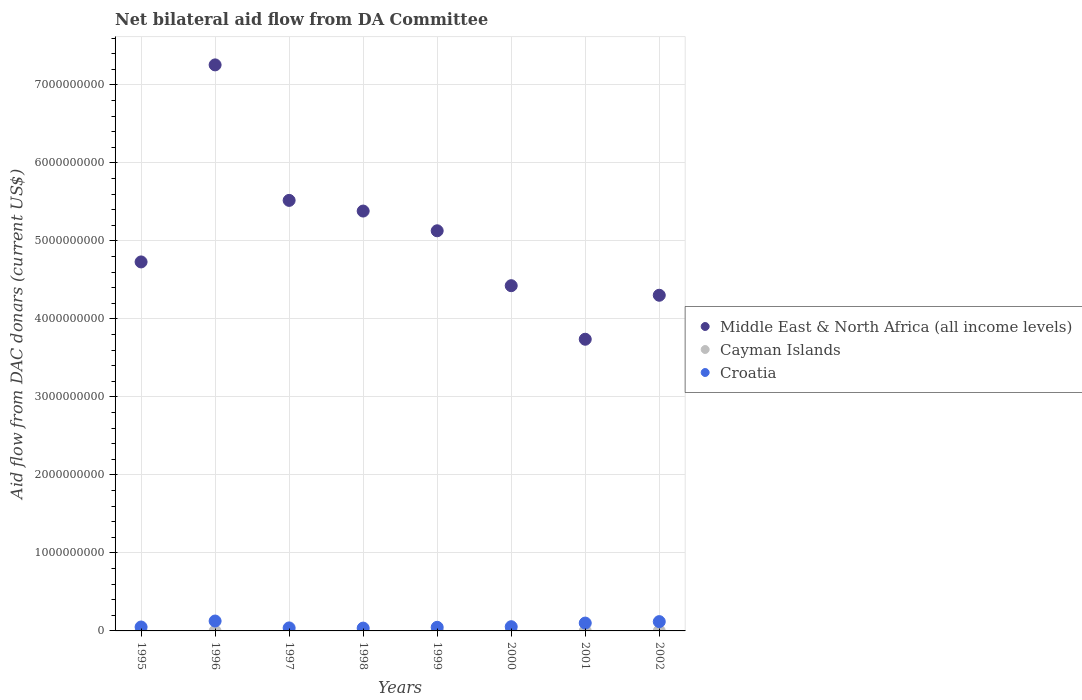What is the aid flow in in Middle East & North Africa (all income levels) in 1997?
Offer a very short reply. 5.52e+09. Across all years, what is the maximum aid flow in in Cayman Islands?
Provide a succinct answer. 3.29e+06. Across all years, what is the minimum aid flow in in Middle East & North Africa (all income levels)?
Make the answer very short. 3.74e+09. What is the total aid flow in in Middle East & North Africa (all income levels) in the graph?
Give a very brief answer. 4.05e+1. What is the difference between the aid flow in in Croatia in 1996 and that in 1999?
Ensure brevity in your answer.  8.06e+07. What is the difference between the aid flow in in Middle East & North Africa (all income levels) in 2002 and the aid flow in in Croatia in 1997?
Ensure brevity in your answer.  4.26e+09. What is the average aid flow in in Cayman Islands per year?
Make the answer very short. 4.40e+05. In the year 1999, what is the difference between the aid flow in in Middle East & North Africa (all income levels) and aid flow in in Cayman Islands?
Your answer should be compact. 5.13e+09. What is the ratio of the aid flow in in Middle East & North Africa (all income levels) in 1997 to that in 2002?
Make the answer very short. 1.28. What is the difference between the highest and the second highest aid flow in in Middle East & North Africa (all income levels)?
Keep it short and to the point. 1.74e+09. What is the difference between the highest and the lowest aid flow in in Middle East & North Africa (all income levels)?
Keep it short and to the point. 3.52e+09. Is it the case that in every year, the sum of the aid flow in in Middle East & North Africa (all income levels) and aid flow in in Cayman Islands  is greater than the aid flow in in Croatia?
Offer a very short reply. Yes. Is the aid flow in in Middle East & North Africa (all income levels) strictly greater than the aid flow in in Croatia over the years?
Make the answer very short. Yes. Is the aid flow in in Cayman Islands strictly less than the aid flow in in Croatia over the years?
Offer a terse response. Yes. How many dotlines are there?
Offer a very short reply. 3. How many years are there in the graph?
Your answer should be very brief. 8. What is the difference between two consecutive major ticks on the Y-axis?
Give a very brief answer. 1.00e+09. Where does the legend appear in the graph?
Ensure brevity in your answer.  Center right. How many legend labels are there?
Ensure brevity in your answer.  3. What is the title of the graph?
Your response must be concise. Net bilateral aid flow from DA Committee. What is the label or title of the X-axis?
Make the answer very short. Years. What is the label or title of the Y-axis?
Provide a succinct answer. Aid flow from DAC donars (current US$). What is the Aid flow from DAC donars (current US$) in Middle East & North Africa (all income levels) in 1995?
Your answer should be very brief. 4.73e+09. What is the Aid flow from DAC donars (current US$) of Cayman Islands in 1995?
Provide a short and direct response. 0. What is the Aid flow from DAC donars (current US$) of Croatia in 1995?
Ensure brevity in your answer.  5.02e+07. What is the Aid flow from DAC donars (current US$) in Middle East & North Africa (all income levels) in 1996?
Ensure brevity in your answer.  7.26e+09. What is the Aid flow from DAC donars (current US$) in Cayman Islands in 1996?
Ensure brevity in your answer.  0. What is the Aid flow from DAC donars (current US$) of Croatia in 1996?
Offer a very short reply. 1.27e+08. What is the Aid flow from DAC donars (current US$) of Middle East & North Africa (all income levels) in 1997?
Ensure brevity in your answer.  5.52e+09. What is the Aid flow from DAC donars (current US$) in Croatia in 1997?
Your answer should be compact. 3.85e+07. What is the Aid flow from DAC donars (current US$) in Middle East & North Africa (all income levels) in 1998?
Your answer should be compact. 5.38e+09. What is the Aid flow from DAC donars (current US$) of Cayman Islands in 1998?
Offer a terse response. 2.30e+05. What is the Aid flow from DAC donars (current US$) in Croatia in 1998?
Your response must be concise. 3.61e+07. What is the Aid flow from DAC donars (current US$) in Middle East & North Africa (all income levels) in 1999?
Your answer should be very brief. 5.13e+09. What is the Aid flow from DAC donars (current US$) in Cayman Islands in 1999?
Provide a succinct answer. 3.29e+06. What is the Aid flow from DAC donars (current US$) in Croatia in 1999?
Provide a short and direct response. 4.63e+07. What is the Aid flow from DAC donars (current US$) in Middle East & North Africa (all income levels) in 2000?
Offer a very short reply. 4.43e+09. What is the Aid flow from DAC donars (current US$) of Cayman Islands in 2000?
Provide a short and direct response. 0. What is the Aid flow from DAC donars (current US$) of Croatia in 2000?
Give a very brief answer. 5.41e+07. What is the Aid flow from DAC donars (current US$) of Middle East & North Africa (all income levels) in 2001?
Offer a terse response. 3.74e+09. What is the Aid flow from DAC donars (current US$) of Cayman Islands in 2001?
Your answer should be very brief. 0. What is the Aid flow from DAC donars (current US$) in Croatia in 2001?
Give a very brief answer. 1.01e+08. What is the Aid flow from DAC donars (current US$) of Middle East & North Africa (all income levels) in 2002?
Your answer should be very brief. 4.30e+09. What is the Aid flow from DAC donars (current US$) of Cayman Islands in 2002?
Provide a succinct answer. 0. What is the Aid flow from DAC donars (current US$) in Croatia in 2002?
Offer a very short reply. 1.19e+08. Across all years, what is the maximum Aid flow from DAC donars (current US$) of Middle East & North Africa (all income levels)?
Offer a very short reply. 7.26e+09. Across all years, what is the maximum Aid flow from DAC donars (current US$) of Cayman Islands?
Provide a succinct answer. 3.29e+06. Across all years, what is the maximum Aid flow from DAC donars (current US$) of Croatia?
Give a very brief answer. 1.27e+08. Across all years, what is the minimum Aid flow from DAC donars (current US$) in Middle East & North Africa (all income levels)?
Offer a terse response. 3.74e+09. Across all years, what is the minimum Aid flow from DAC donars (current US$) in Cayman Islands?
Offer a very short reply. 0. Across all years, what is the minimum Aid flow from DAC donars (current US$) in Croatia?
Offer a terse response. 3.61e+07. What is the total Aid flow from DAC donars (current US$) of Middle East & North Africa (all income levels) in the graph?
Offer a very short reply. 4.05e+1. What is the total Aid flow from DAC donars (current US$) in Cayman Islands in the graph?
Your answer should be compact. 3.52e+06. What is the total Aid flow from DAC donars (current US$) in Croatia in the graph?
Make the answer very short. 5.72e+08. What is the difference between the Aid flow from DAC donars (current US$) of Middle East & North Africa (all income levels) in 1995 and that in 1996?
Give a very brief answer. -2.53e+09. What is the difference between the Aid flow from DAC donars (current US$) of Croatia in 1995 and that in 1996?
Make the answer very short. -7.67e+07. What is the difference between the Aid flow from DAC donars (current US$) in Middle East & North Africa (all income levels) in 1995 and that in 1997?
Your answer should be compact. -7.89e+08. What is the difference between the Aid flow from DAC donars (current US$) in Croatia in 1995 and that in 1997?
Provide a succinct answer. 1.17e+07. What is the difference between the Aid flow from DAC donars (current US$) of Middle East & North Africa (all income levels) in 1995 and that in 1998?
Your response must be concise. -6.52e+08. What is the difference between the Aid flow from DAC donars (current US$) of Croatia in 1995 and that in 1998?
Your response must be concise. 1.41e+07. What is the difference between the Aid flow from DAC donars (current US$) in Middle East & North Africa (all income levels) in 1995 and that in 1999?
Offer a terse response. -3.99e+08. What is the difference between the Aid flow from DAC donars (current US$) of Croatia in 1995 and that in 1999?
Your response must be concise. 3.92e+06. What is the difference between the Aid flow from DAC donars (current US$) of Middle East & North Africa (all income levels) in 1995 and that in 2000?
Offer a very short reply. 3.05e+08. What is the difference between the Aid flow from DAC donars (current US$) in Croatia in 1995 and that in 2000?
Your answer should be very brief. -3.86e+06. What is the difference between the Aid flow from DAC donars (current US$) of Middle East & North Africa (all income levels) in 1995 and that in 2001?
Your answer should be compact. 9.91e+08. What is the difference between the Aid flow from DAC donars (current US$) of Croatia in 1995 and that in 2001?
Keep it short and to the point. -5.04e+07. What is the difference between the Aid flow from DAC donars (current US$) of Middle East & North Africa (all income levels) in 1995 and that in 2002?
Provide a short and direct response. 4.27e+08. What is the difference between the Aid flow from DAC donars (current US$) of Croatia in 1995 and that in 2002?
Provide a short and direct response. -6.90e+07. What is the difference between the Aid flow from DAC donars (current US$) of Middle East & North Africa (all income levels) in 1996 and that in 1997?
Offer a very short reply. 1.74e+09. What is the difference between the Aid flow from DAC donars (current US$) in Croatia in 1996 and that in 1997?
Give a very brief answer. 8.84e+07. What is the difference between the Aid flow from DAC donars (current US$) in Middle East & North Africa (all income levels) in 1996 and that in 1998?
Give a very brief answer. 1.87e+09. What is the difference between the Aid flow from DAC donars (current US$) of Croatia in 1996 and that in 1998?
Keep it short and to the point. 9.08e+07. What is the difference between the Aid flow from DAC donars (current US$) of Middle East & North Africa (all income levels) in 1996 and that in 1999?
Ensure brevity in your answer.  2.13e+09. What is the difference between the Aid flow from DAC donars (current US$) of Croatia in 1996 and that in 1999?
Your response must be concise. 8.06e+07. What is the difference between the Aid flow from DAC donars (current US$) in Middle East & North Africa (all income levels) in 1996 and that in 2000?
Your response must be concise. 2.83e+09. What is the difference between the Aid flow from DAC donars (current US$) in Croatia in 1996 and that in 2000?
Your answer should be compact. 7.28e+07. What is the difference between the Aid flow from DAC donars (current US$) in Middle East & North Africa (all income levels) in 1996 and that in 2001?
Ensure brevity in your answer.  3.52e+09. What is the difference between the Aid flow from DAC donars (current US$) in Croatia in 1996 and that in 2001?
Ensure brevity in your answer.  2.62e+07. What is the difference between the Aid flow from DAC donars (current US$) in Middle East & North Africa (all income levels) in 1996 and that in 2002?
Offer a terse response. 2.95e+09. What is the difference between the Aid flow from DAC donars (current US$) of Croatia in 1996 and that in 2002?
Offer a very short reply. 7.61e+06. What is the difference between the Aid flow from DAC donars (current US$) of Middle East & North Africa (all income levels) in 1997 and that in 1998?
Make the answer very short. 1.37e+08. What is the difference between the Aid flow from DAC donars (current US$) in Croatia in 1997 and that in 1998?
Keep it short and to the point. 2.40e+06. What is the difference between the Aid flow from DAC donars (current US$) in Middle East & North Africa (all income levels) in 1997 and that in 1999?
Make the answer very short. 3.90e+08. What is the difference between the Aid flow from DAC donars (current US$) in Croatia in 1997 and that in 1999?
Give a very brief answer. -7.78e+06. What is the difference between the Aid flow from DAC donars (current US$) in Middle East & North Africa (all income levels) in 1997 and that in 2000?
Your response must be concise. 1.09e+09. What is the difference between the Aid flow from DAC donars (current US$) in Croatia in 1997 and that in 2000?
Your answer should be very brief. -1.56e+07. What is the difference between the Aid flow from DAC donars (current US$) of Middle East & North Africa (all income levels) in 1997 and that in 2001?
Make the answer very short. 1.78e+09. What is the difference between the Aid flow from DAC donars (current US$) of Croatia in 1997 and that in 2001?
Offer a very short reply. -6.21e+07. What is the difference between the Aid flow from DAC donars (current US$) in Middle East & North Africa (all income levels) in 1997 and that in 2002?
Offer a very short reply. 1.22e+09. What is the difference between the Aid flow from DAC donars (current US$) in Croatia in 1997 and that in 2002?
Your response must be concise. -8.08e+07. What is the difference between the Aid flow from DAC donars (current US$) in Middle East & North Africa (all income levels) in 1998 and that in 1999?
Give a very brief answer. 2.53e+08. What is the difference between the Aid flow from DAC donars (current US$) of Cayman Islands in 1998 and that in 1999?
Offer a very short reply. -3.06e+06. What is the difference between the Aid flow from DAC donars (current US$) in Croatia in 1998 and that in 1999?
Offer a terse response. -1.02e+07. What is the difference between the Aid flow from DAC donars (current US$) in Middle East & North Africa (all income levels) in 1998 and that in 2000?
Your answer should be very brief. 9.57e+08. What is the difference between the Aid flow from DAC donars (current US$) of Croatia in 1998 and that in 2000?
Make the answer very short. -1.80e+07. What is the difference between the Aid flow from DAC donars (current US$) in Middle East & North Africa (all income levels) in 1998 and that in 2001?
Your answer should be very brief. 1.64e+09. What is the difference between the Aid flow from DAC donars (current US$) in Croatia in 1998 and that in 2001?
Your response must be concise. -6.45e+07. What is the difference between the Aid flow from DAC donars (current US$) of Middle East & North Africa (all income levels) in 1998 and that in 2002?
Provide a succinct answer. 1.08e+09. What is the difference between the Aid flow from DAC donars (current US$) in Croatia in 1998 and that in 2002?
Your response must be concise. -8.32e+07. What is the difference between the Aid flow from DAC donars (current US$) in Middle East & North Africa (all income levels) in 1999 and that in 2000?
Offer a very short reply. 7.04e+08. What is the difference between the Aid flow from DAC donars (current US$) of Croatia in 1999 and that in 2000?
Offer a terse response. -7.78e+06. What is the difference between the Aid flow from DAC donars (current US$) in Middle East & North Africa (all income levels) in 1999 and that in 2001?
Offer a terse response. 1.39e+09. What is the difference between the Aid flow from DAC donars (current US$) in Croatia in 1999 and that in 2001?
Your response must be concise. -5.44e+07. What is the difference between the Aid flow from DAC donars (current US$) in Middle East & North Africa (all income levels) in 1999 and that in 2002?
Ensure brevity in your answer.  8.26e+08. What is the difference between the Aid flow from DAC donars (current US$) of Croatia in 1999 and that in 2002?
Ensure brevity in your answer.  -7.30e+07. What is the difference between the Aid flow from DAC donars (current US$) of Middle East & North Africa (all income levels) in 2000 and that in 2001?
Provide a short and direct response. 6.86e+08. What is the difference between the Aid flow from DAC donars (current US$) of Croatia in 2000 and that in 2001?
Ensure brevity in your answer.  -4.66e+07. What is the difference between the Aid flow from DAC donars (current US$) in Middle East & North Africa (all income levels) in 2000 and that in 2002?
Ensure brevity in your answer.  1.23e+08. What is the difference between the Aid flow from DAC donars (current US$) of Croatia in 2000 and that in 2002?
Your answer should be very brief. -6.52e+07. What is the difference between the Aid flow from DAC donars (current US$) in Middle East & North Africa (all income levels) in 2001 and that in 2002?
Provide a short and direct response. -5.64e+08. What is the difference between the Aid flow from DAC donars (current US$) in Croatia in 2001 and that in 2002?
Offer a very short reply. -1.86e+07. What is the difference between the Aid flow from DAC donars (current US$) in Middle East & North Africa (all income levels) in 1995 and the Aid flow from DAC donars (current US$) in Croatia in 1996?
Keep it short and to the point. 4.60e+09. What is the difference between the Aid flow from DAC donars (current US$) of Middle East & North Africa (all income levels) in 1995 and the Aid flow from DAC donars (current US$) of Croatia in 1997?
Keep it short and to the point. 4.69e+09. What is the difference between the Aid flow from DAC donars (current US$) of Middle East & North Africa (all income levels) in 1995 and the Aid flow from DAC donars (current US$) of Cayman Islands in 1998?
Offer a very short reply. 4.73e+09. What is the difference between the Aid flow from DAC donars (current US$) of Middle East & North Africa (all income levels) in 1995 and the Aid flow from DAC donars (current US$) of Croatia in 1998?
Your response must be concise. 4.69e+09. What is the difference between the Aid flow from DAC donars (current US$) in Middle East & North Africa (all income levels) in 1995 and the Aid flow from DAC donars (current US$) in Cayman Islands in 1999?
Offer a terse response. 4.73e+09. What is the difference between the Aid flow from DAC donars (current US$) of Middle East & North Africa (all income levels) in 1995 and the Aid flow from DAC donars (current US$) of Croatia in 1999?
Provide a short and direct response. 4.68e+09. What is the difference between the Aid flow from DAC donars (current US$) in Middle East & North Africa (all income levels) in 1995 and the Aid flow from DAC donars (current US$) in Croatia in 2000?
Your response must be concise. 4.68e+09. What is the difference between the Aid flow from DAC donars (current US$) in Middle East & North Africa (all income levels) in 1995 and the Aid flow from DAC donars (current US$) in Croatia in 2001?
Your response must be concise. 4.63e+09. What is the difference between the Aid flow from DAC donars (current US$) in Middle East & North Africa (all income levels) in 1995 and the Aid flow from DAC donars (current US$) in Croatia in 2002?
Your response must be concise. 4.61e+09. What is the difference between the Aid flow from DAC donars (current US$) in Middle East & North Africa (all income levels) in 1996 and the Aid flow from DAC donars (current US$) in Croatia in 1997?
Your response must be concise. 7.22e+09. What is the difference between the Aid flow from DAC donars (current US$) of Middle East & North Africa (all income levels) in 1996 and the Aid flow from DAC donars (current US$) of Cayman Islands in 1998?
Keep it short and to the point. 7.26e+09. What is the difference between the Aid flow from DAC donars (current US$) of Middle East & North Africa (all income levels) in 1996 and the Aid flow from DAC donars (current US$) of Croatia in 1998?
Offer a terse response. 7.22e+09. What is the difference between the Aid flow from DAC donars (current US$) in Middle East & North Africa (all income levels) in 1996 and the Aid flow from DAC donars (current US$) in Cayman Islands in 1999?
Your response must be concise. 7.25e+09. What is the difference between the Aid flow from DAC donars (current US$) in Middle East & North Africa (all income levels) in 1996 and the Aid flow from DAC donars (current US$) in Croatia in 1999?
Your answer should be very brief. 7.21e+09. What is the difference between the Aid flow from DAC donars (current US$) of Middle East & North Africa (all income levels) in 1996 and the Aid flow from DAC donars (current US$) of Croatia in 2000?
Give a very brief answer. 7.20e+09. What is the difference between the Aid flow from DAC donars (current US$) in Middle East & North Africa (all income levels) in 1996 and the Aid flow from DAC donars (current US$) in Croatia in 2001?
Offer a very short reply. 7.16e+09. What is the difference between the Aid flow from DAC donars (current US$) in Middle East & North Africa (all income levels) in 1996 and the Aid flow from DAC donars (current US$) in Croatia in 2002?
Keep it short and to the point. 7.14e+09. What is the difference between the Aid flow from DAC donars (current US$) of Middle East & North Africa (all income levels) in 1997 and the Aid flow from DAC donars (current US$) of Cayman Islands in 1998?
Offer a terse response. 5.52e+09. What is the difference between the Aid flow from DAC donars (current US$) of Middle East & North Africa (all income levels) in 1997 and the Aid flow from DAC donars (current US$) of Croatia in 1998?
Your answer should be compact. 5.48e+09. What is the difference between the Aid flow from DAC donars (current US$) in Middle East & North Africa (all income levels) in 1997 and the Aid flow from DAC donars (current US$) in Cayman Islands in 1999?
Offer a very short reply. 5.52e+09. What is the difference between the Aid flow from DAC donars (current US$) in Middle East & North Africa (all income levels) in 1997 and the Aid flow from DAC donars (current US$) in Croatia in 1999?
Ensure brevity in your answer.  5.47e+09. What is the difference between the Aid flow from DAC donars (current US$) in Middle East & North Africa (all income levels) in 1997 and the Aid flow from DAC donars (current US$) in Croatia in 2000?
Offer a terse response. 5.46e+09. What is the difference between the Aid flow from DAC donars (current US$) of Middle East & North Africa (all income levels) in 1997 and the Aid flow from DAC donars (current US$) of Croatia in 2001?
Keep it short and to the point. 5.42e+09. What is the difference between the Aid flow from DAC donars (current US$) of Middle East & North Africa (all income levels) in 1997 and the Aid flow from DAC donars (current US$) of Croatia in 2002?
Offer a very short reply. 5.40e+09. What is the difference between the Aid flow from DAC donars (current US$) of Middle East & North Africa (all income levels) in 1998 and the Aid flow from DAC donars (current US$) of Cayman Islands in 1999?
Keep it short and to the point. 5.38e+09. What is the difference between the Aid flow from DAC donars (current US$) of Middle East & North Africa (all income levels) in 1998 and the Aid flow from DAC donars (current US$) of Croatia in 1999?
Your answer should be very brief. 5.34e+09. What is the difference between the Aid flow from DAC donars (current US$) in Cayman Islands in 1998 and the Aid flow from DAC donars (current US$) in Croatia in 1999?
Give a very brief answer. -4.61e+07. What is the difference between the Aid flow from DAC donars (current US$) in Middle East & North Africa (all income levels) in 1998 and the Aid flow from DAC donars (current US$) in Croatia in 2000?
Make the answer very short. 5.33e+09. What is the difference between the Aid flow from DAC donars (current US$) of Cayman Islands in 1998 and the Aid flow from DAC donars (current US$) of Croatia in 2000?
Your answer should be very brief. -5.38e+07. What is the difference between the Aid flow from DAC donars (current US$) of Middle East & North Africa (all income levels) in 1998 and the Aid flow from DAC donars (current US$) of Croatia in 2001?
Ensure brevity in your answer.  5.28e+09. What is the difference between the Aid flow from DAC donars (current US$) of Cayman Islands in 1998 and the Aid flow from DAC donars (current US$) of Croatia in 2001?
Your answer should be compact. -1.00e+08. What is the difference between the Aid flow from DAC donars (current US$) in Middle East & North Africa (all income levels) in 1998 and the Aid flow from DAC donars (current US$) in Croatia in 2002?
Keep it short and to the point. 5.26e+09. What is the difference between the Aid flow from DAC donars (current US$) of Cayman Islands in 1998 and the Aid flow from DAC donars (current US$) of Croatia in 2002?
Offer a terse response. -1.19e+08. What is the difference between the Aid flow from DAC donars (current US$) in Middle East & North Africa (all income levels) in 1999 and the Aid flow from DAC donars (current US$) in Croatia in 2000?
Keep it short and to the point. 5.08e+09. What is the difference between the Aid flow from DAC donars (current US$) in Cayman Islands in 1999 and the Aid flow from DAC donars (current US$) in Croatia in 2000?
Give a very brief answer. -5.08e+07. What is the difference between the Aid flow from DAC donars (current US$) of Middle East & North Africa (all income levels) in 1999 and the Aid flow from DAC donars (current US$) of Croatia in 2001?
Keep it short and to the point. 5.03e+09. What is the difference between the Aid flow from DAC donars (current US$) in Cayman Islands in 1999 and the Aid flow from DAC donars (current US$) in Croatia in 2001?
Make the answer very short. -9.74e+07. What is the difference between the Aid flow from DAC donars (current US$) of Middle East & North Africa (all income levels) in 1999 and the Aid flow from DAC donars (current US$) of Croatia in 2002?
Provide a succinct answer. 5.01e+09. What is the difference between the Aid flow from DAC donars (current US$) of Cayman Islands in 1999 and the Aid flow from DAC donars (current US$) of Croatia in 2002?
Your response must be concise. -1.16e+08. What is the difference between the Aid flow from DAC donars (current US$) of Middle East & North Africa (all income levels) in 2000 and the Aid flow from DAC donars (current US$) of Croatia in 2001?
Provide a short and direct response. 4.32e+09. What is the difference between the Aid flow from DAC donars (current US$) in Middle East & North Africa (all income levels) in 2000 and the Aid flow from DAC donars (current US$) in Croatia in 2002?
Your answer should be compact. 4.31e+09. What is the difference between the Aid flow from DAC donars (current US$) of Middle East & North Africa (all income levels) in 2001 and the Aid flow from DAC donars (current US$) of Croatia in 2002?
Keep it short and to the point. 3.62e+09. What is the average Aid flow from DAC donars (current US$) of Middle East & North Africa (all income levels) per year?
Your answer should be very brief. 5.06e+09. What is the average Aid flow from DAC donars (current US$) of Croatia per year?
Your answer should be very brief. 7.15e+07. In the year 1995, what is the difference between the Aid flow from DAC donars (current US$) of Middle East & North Africa (all income levels) and Aid flow from DAC donars (current US$) of Croatia?
Ensure brevity in your answer.  4.68e+09. In the year 1996, what is the difference between the Aid flow from DAC donars (current US$) in Middle East & North Africa (all income levels) and Aid flow from DAC donars (current US$) in Croatia?
Offer a very short reply. 7.13e+09. In the year 1997, what is the difference between the Aid flow from DAC donars (current US$) of Middle East & North Africa (all income levels) and Aid flow from DAC donars (current US$) of Croatia?
Provide a short and direct response. 5.48e+09. In the year 1998, what is the difference between the Aid flow from DAC donars (current US$) in Middle East & North Africa (all income levels) and Aid flow from DAC donars (current US$) in Cayman Islands?
Offer a terse response. 5.38e+09. In the year 1998, what is the difference between the Aid flow from DAC donars (current US$) of Middle East & North Africa (all income levels) and Aid flow from DAC donars (current US$) of Croatia?
Offer a very short reply. 5.35e+09. In the year 1998, what is the difference between the Aid flow from DAC donars (current US$) of Cayman Islands and Aid flow from DAC donars (current US$) of Croatia?
Offer a very short reply. -3.59e+07. In the year 1999, what is the difference between the Aid flow from DAC donars (current US$) in Middle East & North Africa (all income levels) and Aid flow from DAC donars (current US$) in Cayman Islands?
Keep it short and to the point. 5.13e+09. In the year 1999, what is the difference between the Aid flow from DAC donars (current US$) of Middle East & North Africa (all income levels) and Aid flow from DAC donars (current US$) of Croatia?
Make the answer very short. 5.08e+09. In the year 1999, what is the difference between the Aid flow from DAC donars (current US$) of Cayman Islands and Aid flow from DAC donars (current US$) of Croatia?
Your answer should be compact. -4.30e+07. In the year 2000, what is the difference between the Aid flow from DAC donars (current US$) of Middle East & North Africa (all income levels) and Aid flow from DAC donars (current US$) of Croatia?
Your response must be concise. 4.37e+09. In the year 2001, what is the difference between the Aid flow from DAC donars (current US$) of Middle East & North Africa (all income levels) and Aid flow from DAC donars (current US$) of Croatia?
Provide a succinct answer. 3.64e+09. In the year 2002, what is the difference between the Aid flow from DAC donars (current US$) in Middle East & North Africa (all income levels) and Aid flow from DAC donars (current US$) in Croatia?
Your answer should be compact. 4.18e+09. What is the ratio of the Aid flow from DAC donars (current US$) of Middle East & North Africa (all income levels) in 1995 to that in 1996?
Keep it short and to the point. 0.65. What is the ratio of the Aid flow from DAC donars (current US$) in Croatia in 1995 to that in 1996?
Make the answer very short. 0.4. What is the ratio of the Aid flow from DAC donars (current US$) of Middle East & North Africa (all income levels) in 1995 to that in 1997?
Your answer should be very brief. 0.86. What is the ratio of the Aid flow from DAC donars (current US$) of Croatia in 1995 to that in 1997?
Ensure brevity in your answer.  1.3. What is the ratio of the Aid flow from DAC donars (current US$) in Middle East & North Africa (all income levels) in 1995 to that in 1998?
Your response must be concise. 0.88. What is the ratio of the Aid flow from DAC donars (current US$) of Croatia in 1995 to that in 1998?
Keep it short and to the point. 1.39. What is the ratio of the Aid flow from DAC donars (current US$) in Middle East & North Africa (all income levels) in 1995 to that in 1999?
Offer a very short reply. 0.92. What is the ratio of the Aid flow from DAC donars (current US$) in Croatia in 1995 to that in 1999?
Your answer should be compact. 1.08. What is the ratio of the Aid flow from DAC donars (current US$) of Middle East & North Africa (all income levels) in 1995 to that in 2000?
Ensure brevity in your answer.  1.07. What is the ratio of the Aid flow from DAC donars (current US$) in Middle East & North Africa (all income levels) in 1995 to that in 2001?
Offer a terse response. 1.27. What is the ratio of the Aid flow from DAC donars (current US$) in Croatia in 1995 to that in 2001?
Provide a succinct answer. 0.5. What is the ratio of the Aid flow from DAC donars (current US$) of Middle East & North Africa (all income levels) in 1995 to that in 2002?
Your response must be concise. 1.1. What is the ratio of the Aid flow from DAC donars (current US$) of Croatia in 1995 to that in 2002?
Your answer should be very brief. 0.42. What is the ratio of the Aid flow from DAC donars (current US$) of Middle East & North Africa (all income levels) in 1996 to that in 1997?
Offer a terse response. 1.31. What is the ratio of the Aid flow from DAC donars (current US$) of Croatia in 1996 to that in 1997?
Give a very brief answer. 3.29. What is the ratio of the Aid flow from DAC donars (current US$) in Middle East & North Africa (all income levels) in 1996 to that in 1998?
Offer a very short reply. 1.35. What is the ratio of the Aid flow from DAC donars (current US$) in Croatia in 1996 to that in 1998?
Provide a succinct answer. 3.51. What is the ratio of the Aid flow from DAC donars (current US$) of Middle East & North Africa (all income levels) in 1996 to that in 1999?
Offer a very short reply. 1.41. What is the ratio of the Aid flow from DAC donars (current US$) of Croatia in 1996 to that in 1999?
Provide a short and direct response. 2.74. What is the ratio of the Aid flow from DAC donars (current US$) in Middle East & North Africa (all income levels) in 1996 to that in 2000?
Provide a succinct answer. 1.64. What is the ratio of the Aid flow from DAC donars (current US$) in Croatia in 1996 to that in 2000?
Ensure brevity in your answer.  2.35. What is the ratio of the Aid flow from DAC donars (current US$) in Middle East & North Africa (all income levels) in 1996 to that in 2001?
Provide a short and direct response. 1.94. What is the ratio of the Aid flow from DAC donars (current US$) of Croatia in 1996 to that in 2001?
Provide a short and direct response. 1.26. What is the ratio of the Aid flow from DAC donars (current US$) of Middle East & North Africa (all income levels) in 1996 to that in 2002?
Keep it short and to the point. 1.69. What is the ratio of the Aid flow from DAC donars (current US$) of Croatia in 1996 to that in 2002?
Your response must be concise. 1.06. What is the ratio of the Aid flow from DAC donars (current US$) of Middle East & North Africa (all income levels) in 1997 to that in 1998?
Provide a short and direct response. 1.03. What is the ratio of the Aid flow from DAC donars (current US$) in Croatia in 1997 to that in 1998?
Give a very brief answer. 1.07. What is the ratio of the Aid flow from DAC donars (current US$) in Middle East & North Africa (all income levels) in 1997 to that in 1999?
Give a very brief answer. 1.08. What is the ratio of the Aid flow from DAC donars (current US$) in Croatia in 1997 to that in 1999?
Your response must be concise. 0.83. What is the ratio of the Aid flow from DAC donars (current US$) of Middle East & North Africa (all income levels) in 1997 to that in 2000?
Provide a succinct answer. 1.25. What is the ratio of the Aid flow from DAC donars (current US$) of Croatia in 1997 to that in 2000?
Provide a short and direct response. 0.71. What is the ratio of the Aid flow from DAC donars (current US$) in Middle East & North Africa (all income levels) in 1997 to that in 2001?
Your response must be concise. 1.48. What is the ratio of the Aid flow from DAC donars (current US$) in Croatia in 1997 to that in 2001?
Your response must be concise. 0.38. What is the ratio of the Aid flow from DAC donars (current US$) of Middle East & North Africa (all income levels) in 1997 to that in 2002?
Your answer should be very brief. 1.28. What is the ratio of the Aid flow from DAC donars (current US$) in Croatia in 1997 to that in 2002?
Offer a terse response. 0.32. What is the ratio of the Aid flow from DAC donars (current US$) of Middle East & North Africa (all income levels) in 1998 to that in 1999?
Your response must be concise. 1.05. What is the ratio of the Aid flow from DAC donars (current US$) in Cayman Islands in 1998 to that in 1999?
Your answer should be very brief. 0.07. What is the ratio of the Aid flow from DAC donars (current US$) in Croatia in 1998 to that in 1999?
Your answer should be very brief. 0.78. What is the ratio of the Aid flow from DAC donars (current US$) in Middle East & North Africa (all income levels) in 1998 to that in 2000?
Your answer should be very brief. 1.22. What is the ratio of the Aid flow from DAC donars (current US$) in Croatia in 1998 to that in 2000?
Make the answer very short. 0.67. What is the ratio of the Aid flow from DAC donars (current US$) in Middle East & North Africa (all income levels) in 1998 to that in 2001?
Offer a very short reply. 1.44. What is the ratio of the Aid flow from DAC donars (current US$) in Croatia in 1998 to that in 2001?
Your answer should be compact. 0.36. What is the ratio of the Aid flow from DAC donars (current US$) of Middle East & North Africa (all income levels) in 1998 to that in 2002?
Offer a terse response. 1.25. What is the ratio of the Aid flow from DAC donars (current US$) in Croatia in 1998 to that in 2002?
Provide a short and direct response. 0.3. What is the ratio of the Aid flow from DAC donars (current US$) of Middle East & North Africa (all income levels) in 1999 to that in 2000?
Keep it short and to the point. 1.16. What is the ratio of the Aid flow from DAC donars (current US$) of Croatia in 1999 to that in 2000?
Your answer should be compact. 0.86. What is the ratio of the Aid flow from DAC donars (current US$) of Middle East & North Africa (all income levels) in 1999 to that in 2001?
Give a very brief answer. 1.37. What is the ratio of the Aid flow from DAC donars (current US$) in Croatia in 1999 to that in 2001?
Your response must be concise. 0.46. What is the ratio of the Aid flow from DAC donars (current US$) of Middle East & North Africa (all income levels) in 1999 to that in 2002?
Your response must be concise. 1.19. What is the ratio of the Aid flow from DAC donars (current US$) in Croatia in 1999 to that in 2002?
Keep it short and to the point. 0.39. What is the ratio of the Aid flow from DAC donars (current US$) in Middle East & North Africa (all income levels) in 2000 to that in 2001?
Make the answer very short. 1.18. What is the ratio of the Aid flow from DAC donars (current US$) in Croatia in 2000 to that in 2001?
Offer a terse response. 0.54. What is the ratio of the Aid flow from DAC donars (current US$) in Middle East & North Africa (all income levels) in 2000 to that in 2002?
Make the answer very short. 1.03. What is the ratio of the Aid flow from DAC donars (current US$) of Croatia in 2000 to that in 2002?
Offer a very short reply. 0.45. What is the ratio of the Aid flow from DAC donars (current US$) in Middle East & North Africa (all income levels) in 2001 to that in 2002?
Provide a short and direct response. 0.87. What is the ratio of the Aid flow from DAC donars (current US$) in Croatia in 2001 to that in 2002?
Give a very brief answer. 0.84. What is the difference between the highest and the second highest Aid flow from DAC donars (current US$) in Middle East & North Africa (all income levels)?
Offer a very short reply. 1.74e+09. What is the difference between the highest and the second highest Aid flow from DAC donars (current US$) in Croatia?
Offer a terse response. 7.61e+06. What is the difference between the highest and the lowest Aid flow from DAC donars (current US$) in Middle East & North Africa (all income levels)?
Keep it short and to the point. 3.52e+09. What is the difference between the highest and the lowest Aid flow from DAC donars (current US$) of Cayman Islands?
Your response must be concise. 3.29e+06. What is the difference between the highest and the lowest Aid flow from DAC donars (current US$) in Croatia?
Ensure brevity in your answer.  9.08e+07. 